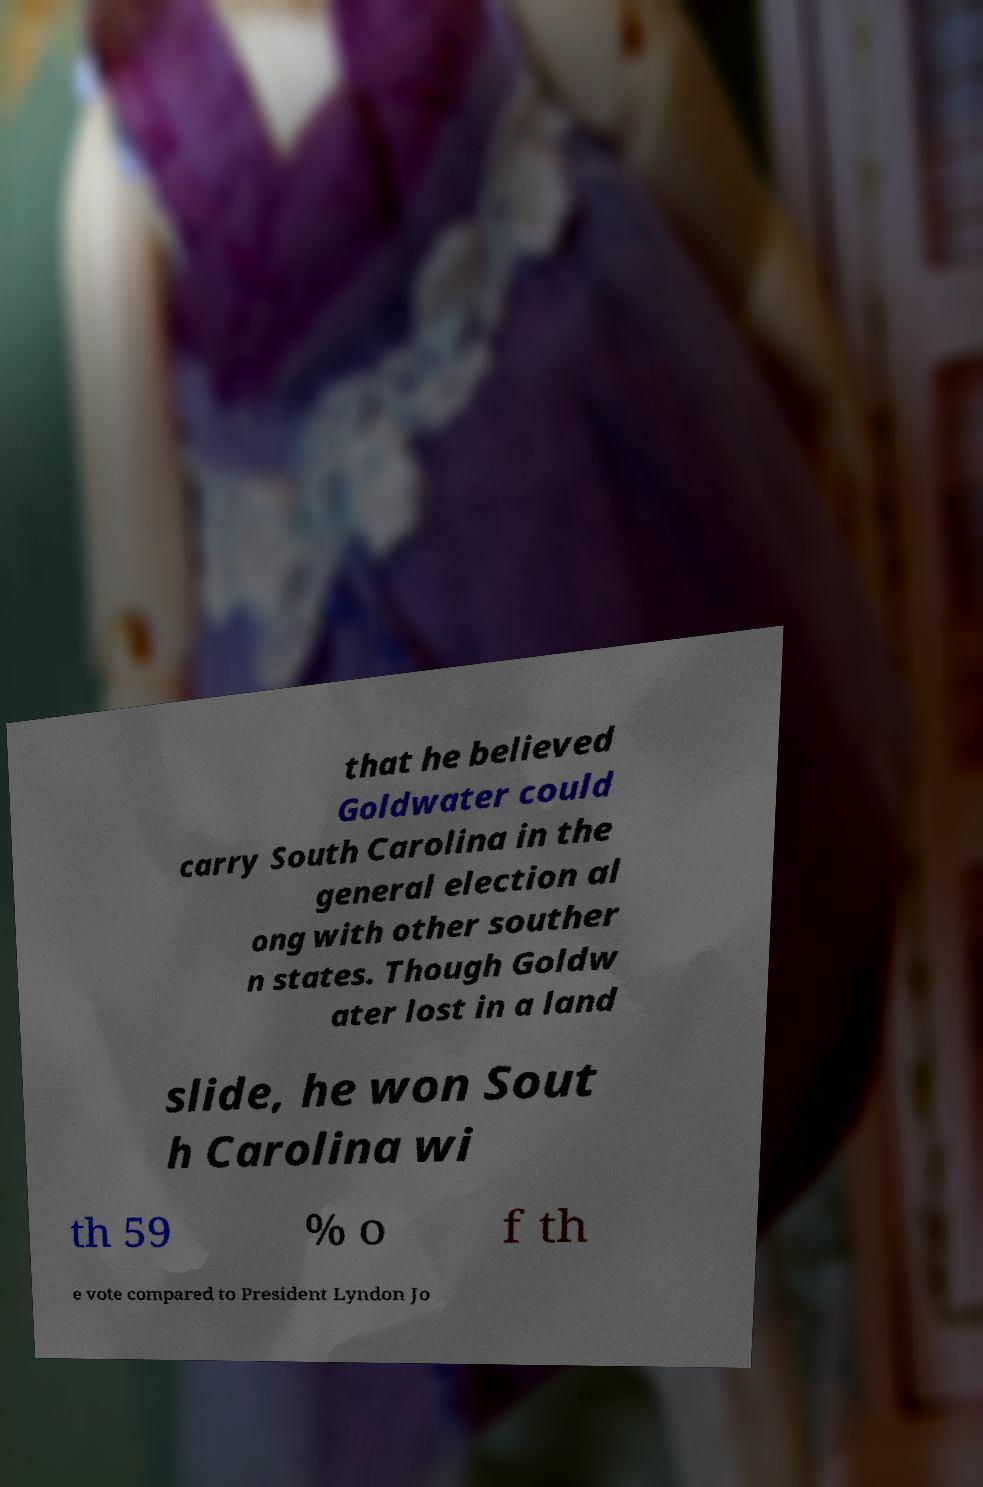I need the written content from this picture converted into text. Can you do that? that he believed Goldwater could carry South Carolina in the general election al ong with other souther n states. Though Goldw ater lost in a land slide, he won Sout h Carolina wi th 59 % o f th e vote compared to President Lyndon Jo 